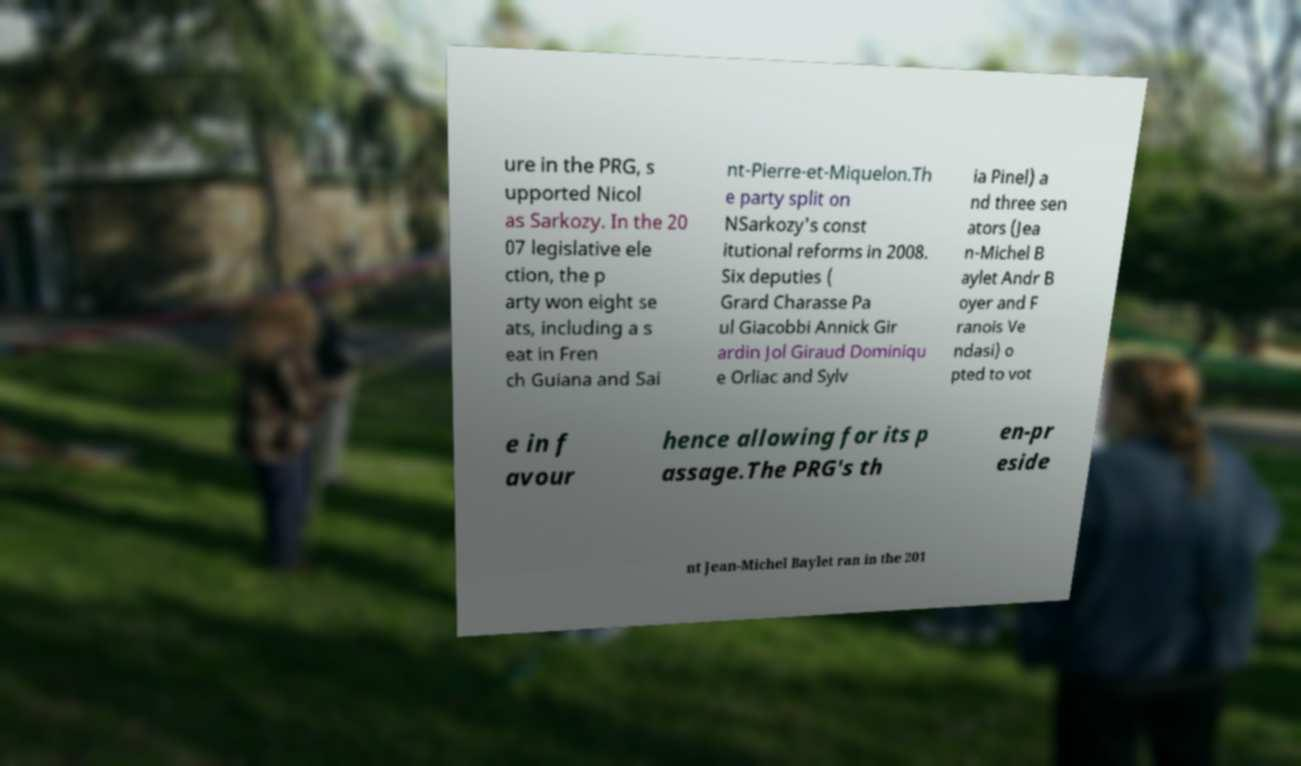Could you extract and type out the text from this image? ure in the PRG, s upported Nicol as Sarkozy. In the 20 07 legislative ele ction, the p arty won eight se ats, including a s eat in Fren ch Guiana and Sai nt-Pierre-et-Miquelon.Th e party split on NSarkozy's const itutional reforms in 2008. Six deputies ( Grard Charasse Pa ul Giacobbi Annick Gir ardin Jol Giraud Dominiqu e Orliac and Sylv ia Pinel) a nd three sen ators (Jea n-Michel B aylet Andr B oyer and F ranois Ve ndasi) o pted to vot e in f avour hence allowing for its p assage.The PRG's th en-pr eside nt Jean-Michel Baylet ran in the 201 